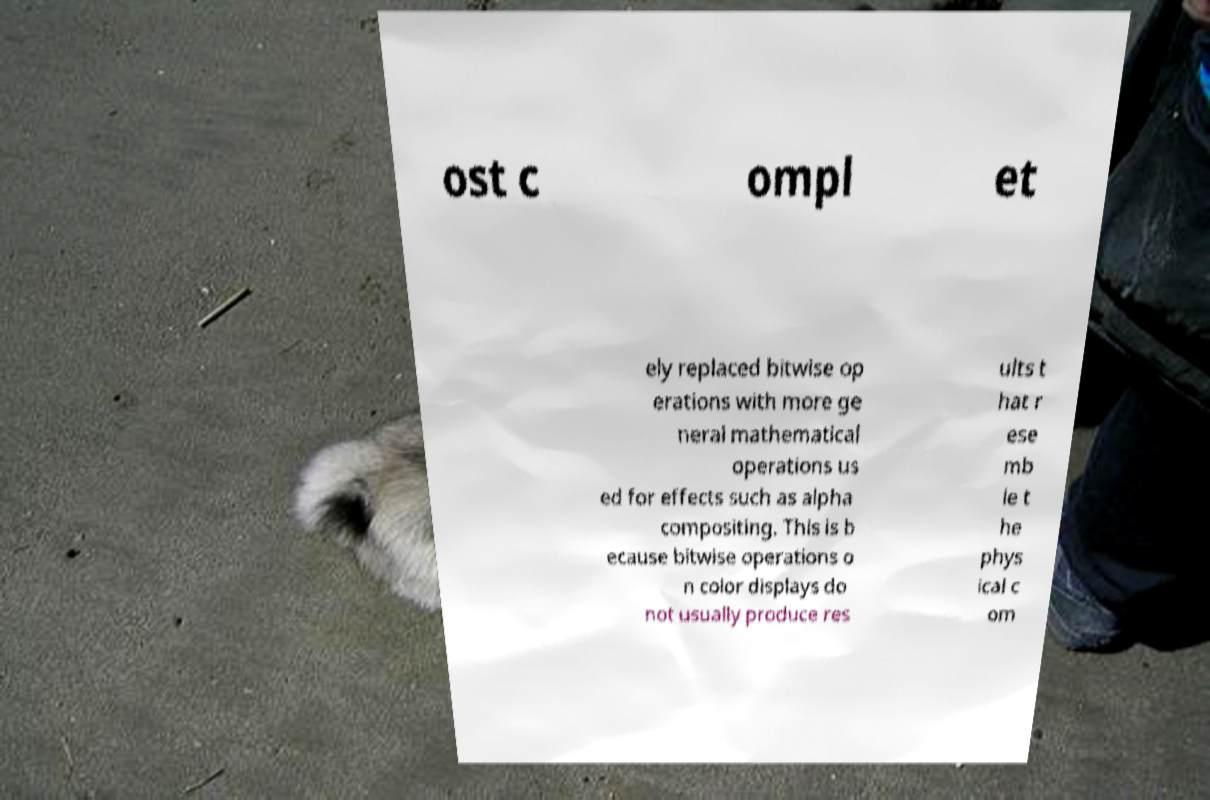Can you read and provide the text displayed in the image?This photo seems to have some interesting text. Can you extract and type it out for me? ost c ompl et ely replaced bitwise op erations with more ge neral mathematical operations us ed for effects such as alpha compositing. This is b ecause bitwise operations o n color displays do not usually produce res ults t hat r ese mb le t he phys ical c om 